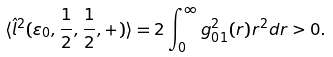<formula> <loc_0><loc_0><loc_500><loc_500>\langle \hat { l } ^ { 2 } ( \varepsilon _ { 0 } , { \frac { 1 } { 2 } } , { \frac { 1 } { 2 } } , + ) \rangle = 2 \int _ { 0 } ^ { \infty } g _ { 0 1 } ^ { 2 } ( r ) r ^ { 2 } d r > 0 .</formula> 